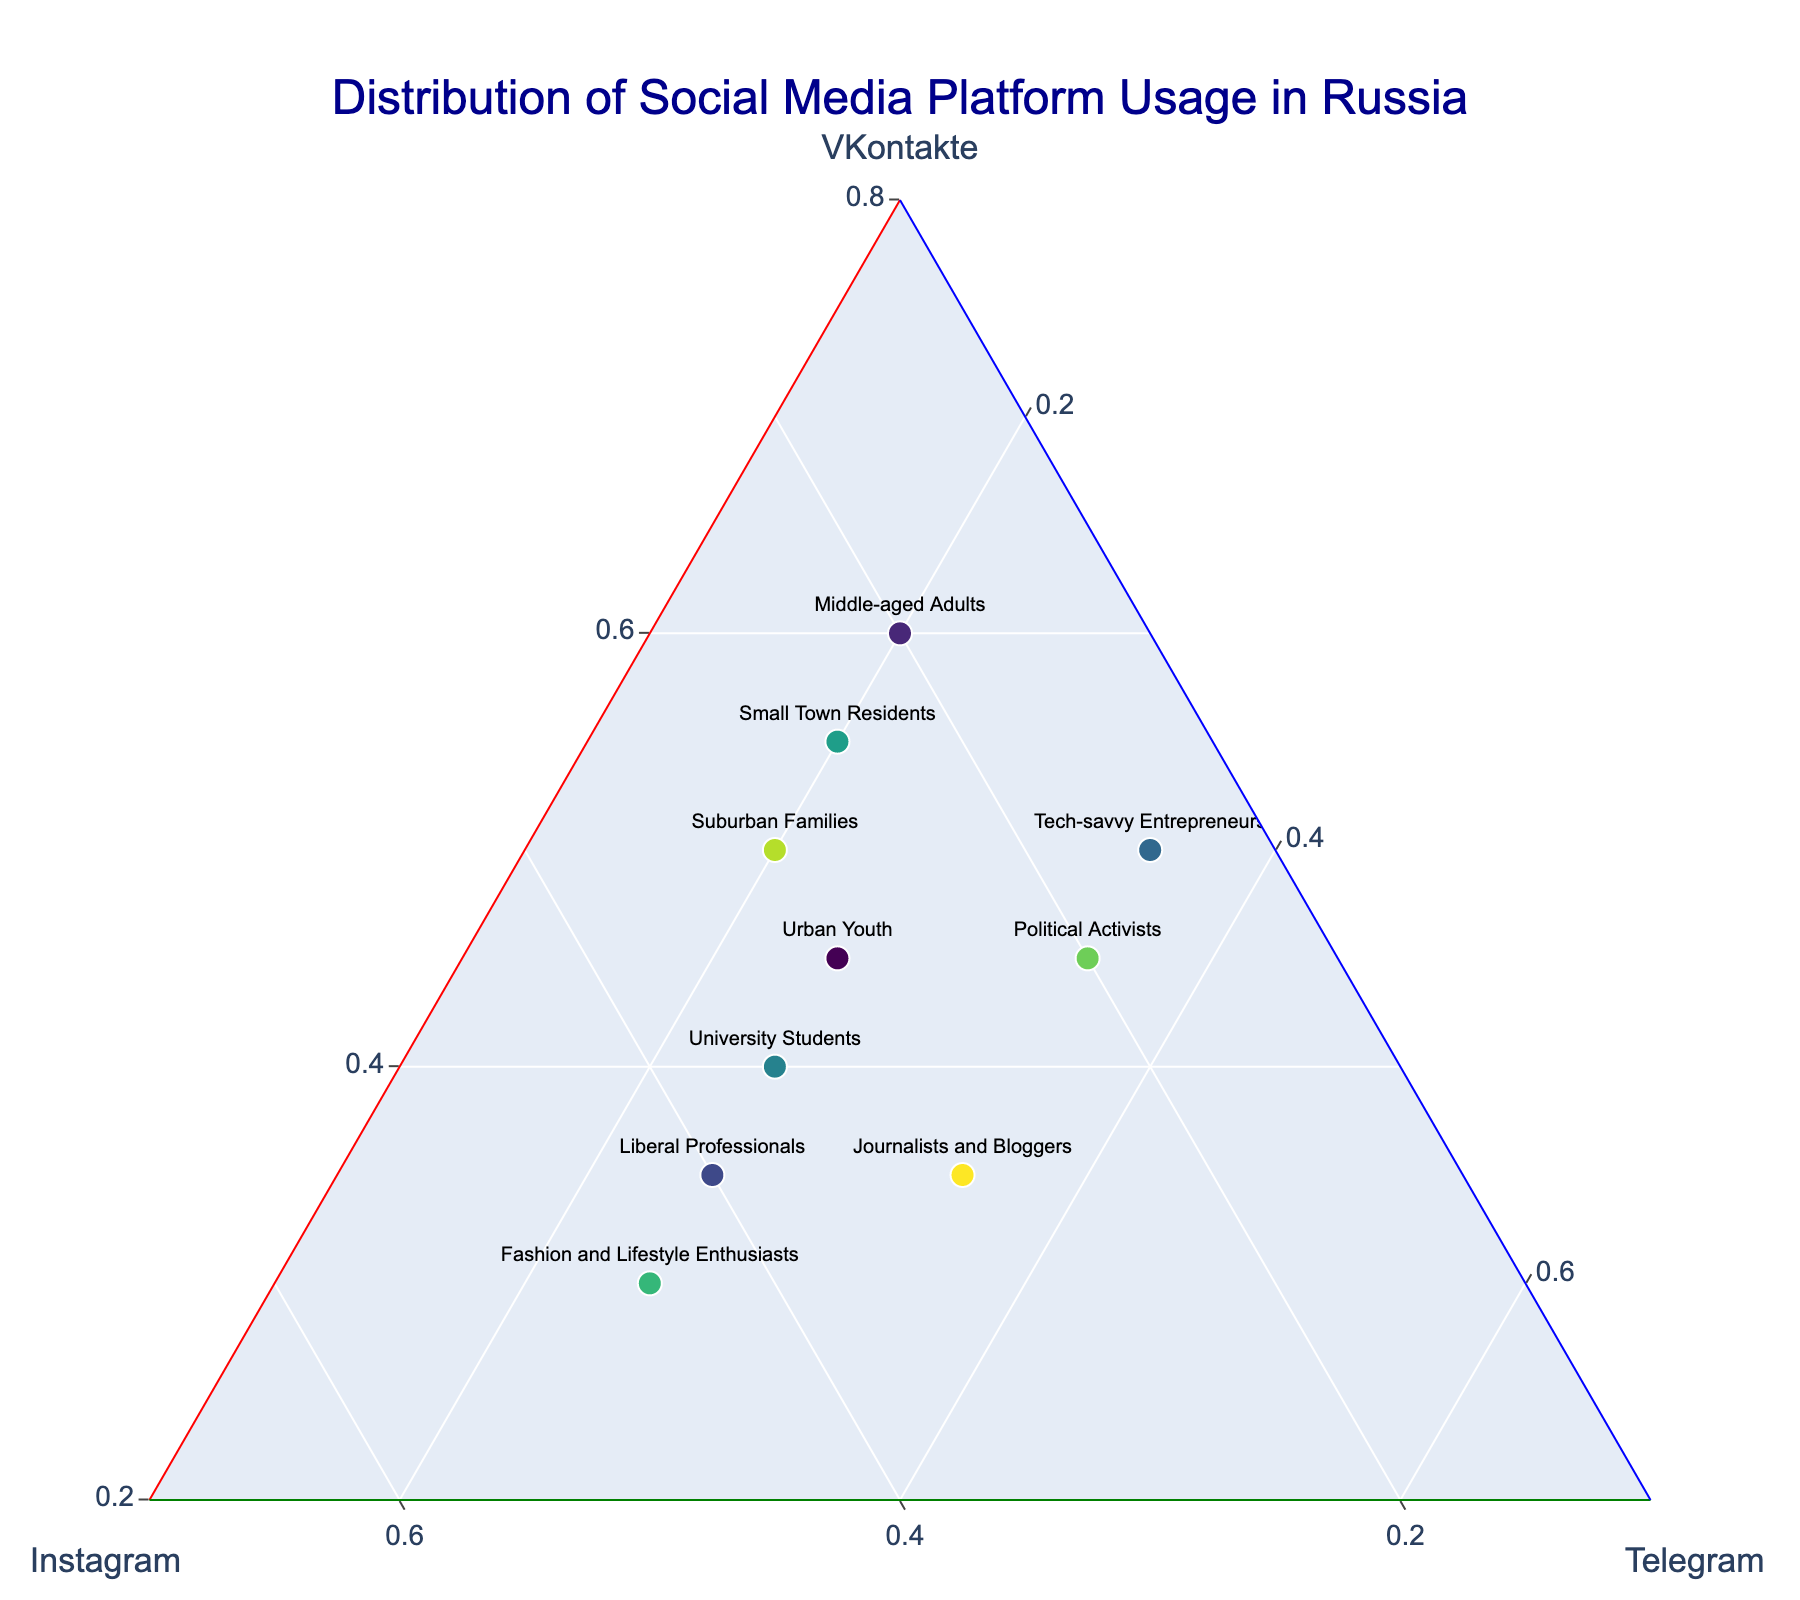Which group uses Instagram the least? Look for the data point with the lowest Instagram proportion on the ternary plot. Suburban Families has the smallest Instagram share.
Answer: Suburban Families Which group uses VKontakte the most? Identify the data point with the highest proportion along the VKontakte axis. Middle-aged Adults has the highest VKontakte share.
Answer: Middle-aged Adults Which groups have equal usage of Instagram? Compare the 'b' coordinates (Instagram normalized values) of all groups to find identical values. Both Liberal Professionals and University Students use Instagram equally.
Answer: Liberal Professionals, University Students What is the common trend between Telegram preferences across all groups? Examine the 'c' coordinates (Telegram normalized values) of all groups and determine the range. The usage of Telegram typically ranges from 20-35% across most groups.
Answer: 20-35% How does the social media usage of Fashion and Lifestyle Enthusiasts compare to Small Town Residents in terms of Instagram? Compare their 'b' coordinates (Instagram normalized values). Fashion and Lifestyle Enthusiasts have 45% Instagram usage, higher than 25% of Small Town Residents.
Answer: Fashion and Lifestyle Enthusiasts use Instagram more than Small Town Residents Which group balances their usage the most across all three platforms? Identify the point closest to the center of the ternary plot where all three proportions are nearly equal. Urban Youth displays a relatively balanced distribution of social media usage.
Answer: Urban Youth How do University Students' and Tech-savvy Entrepreneurs' usages of Telegram compare? Compare the 'c' coordinates (Telegram normalized values) of both groups. University Students have 25% Telegram usage, and Tech-savvy Entrepreneurs have 35% Telegram usage.
Answer: Tech-savvy Entrepreneurs use Telegram more than University Students Which group has the most significant preference for Telegram and the least interaction with Instagram? Find the group with the highest 'c' coordinate and lowest 'b' coordinate. Tech-savvy Entrepreneurs has a high Telegram usage (35%) and low Instagram usage (15%).
Answer: Tech-savvy Entrepreneurs How does the usage of VKontakte by Journalists and Bloggers differ from that of Liberal Professionals? Compare the 'a' coordinates (VKontakte normalized values) of both groups. Journalists and Bloggers have 35% VKontakte, Liberal Professionals have 35%.
Answer: They are the same 